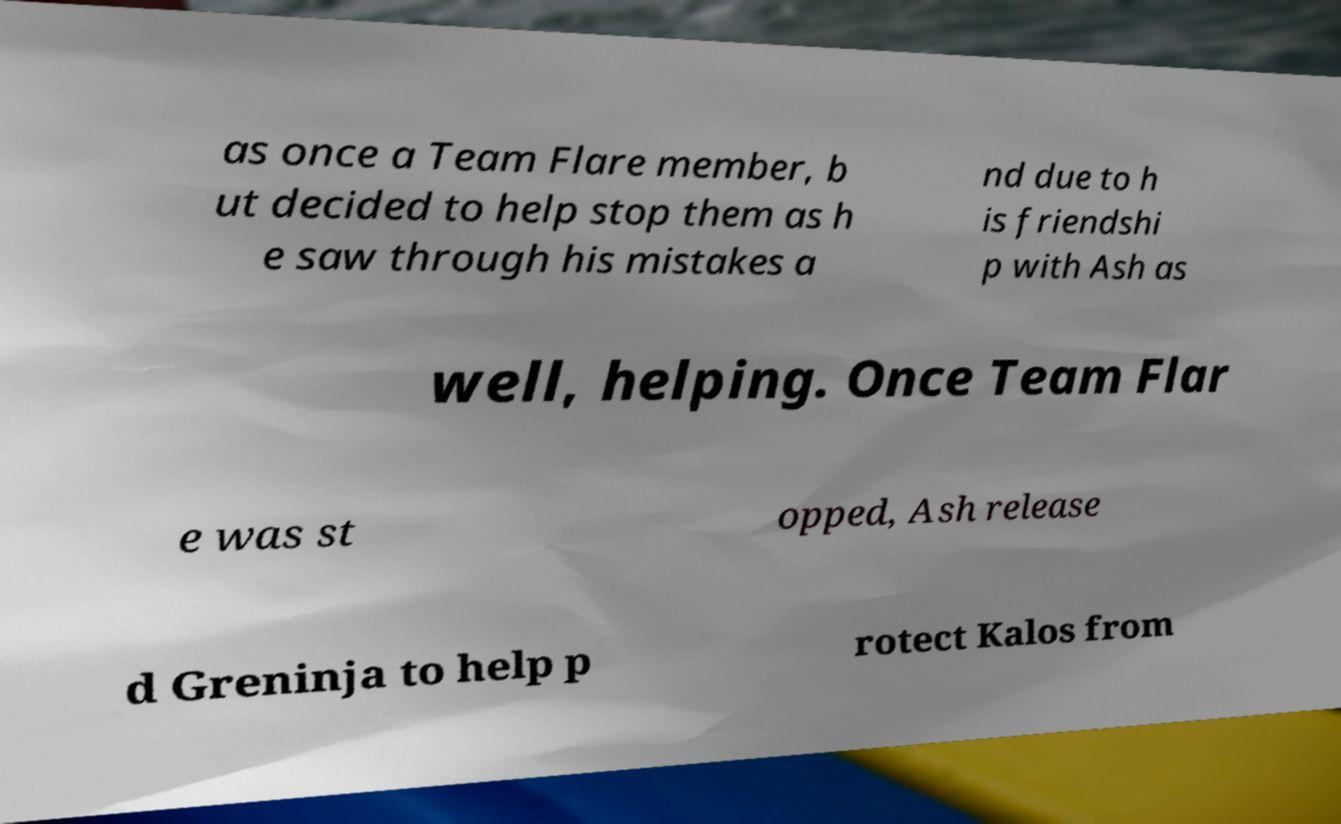I need the written content from this picture converted into text. Can you do that? as once a Team Flare member, b ut decided to help stop them as h e saw through his mistakes a nd due to h is friendshi p with Ash as well, helping. Once Team Flar e was st opped, Ash release d Greninja to help p rotect Kalos from 